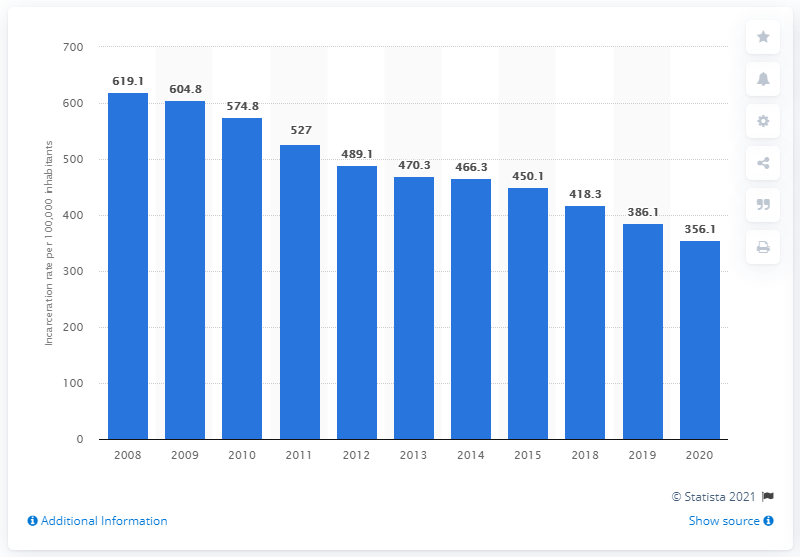Indicate a few pertinent items in this graphic. In the decade prior, the incarceration rate in Russia was 574.8 per 100,000 population. In 2020, the incarceration rate in Russia was 356.1 per 100,000 inhabitants. 